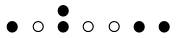Convert formula to latex. <formula><loc_0><loc_0><loc_500><loc_500>\begin{smallmatrix} & & \bullet \\ \bullet & \circ & \bullet & \circ & \circ & \bullet & \bullet & \\ \end{smallmatrix}</formula> 